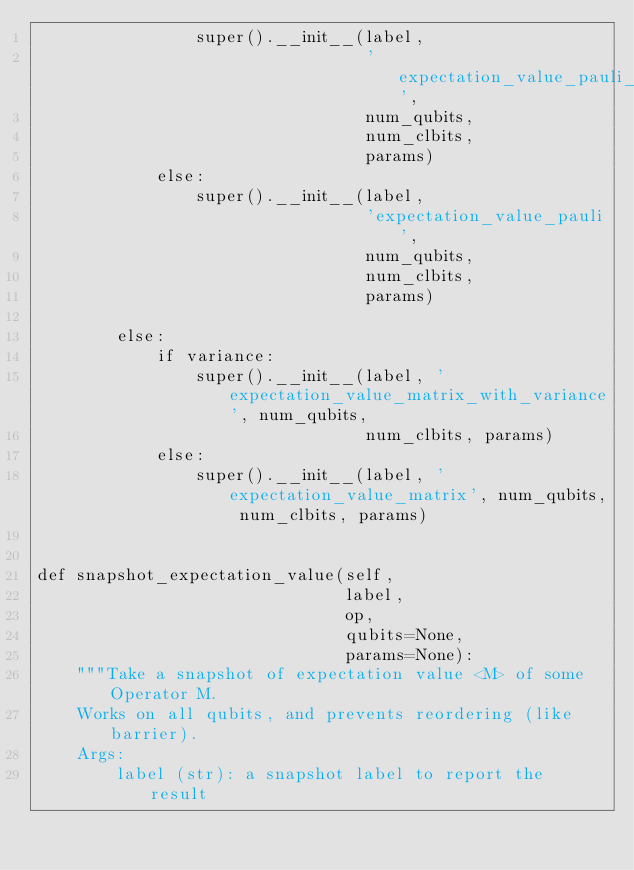<code> <loc_0><loc_0><loc_500><loc_500><_Python_>                super().__init__(label,
                                 'expectation_value_pauli_with_variance',
                                 num_qubits,
                                 num_clbits,
                                 params)
            else:
                super().__init__(label,
                                 'expectation_value_pauli',
                                 num_qubits,
                                 num_clbits,
                                 params)

        else:
            if variance:
                super().__init__(label, 'expectation_value_matrix_with_variance', num_qubits,
                                 num_clbits, params)
            else:
                super().__init__(label, 'expectation_value_matrix', num_qubits, num_clbits, params)


def snapshot_expectation_value(self,
                               label,
                               op,
                               qubits=None,
                               params=None):
    """Take a snapshot of expectation value <M> of some Operator M.
    Works on all qubits, and prevents reordering (like barrier).
    Args:
        label (str): a snapshot label to report the result</code> 